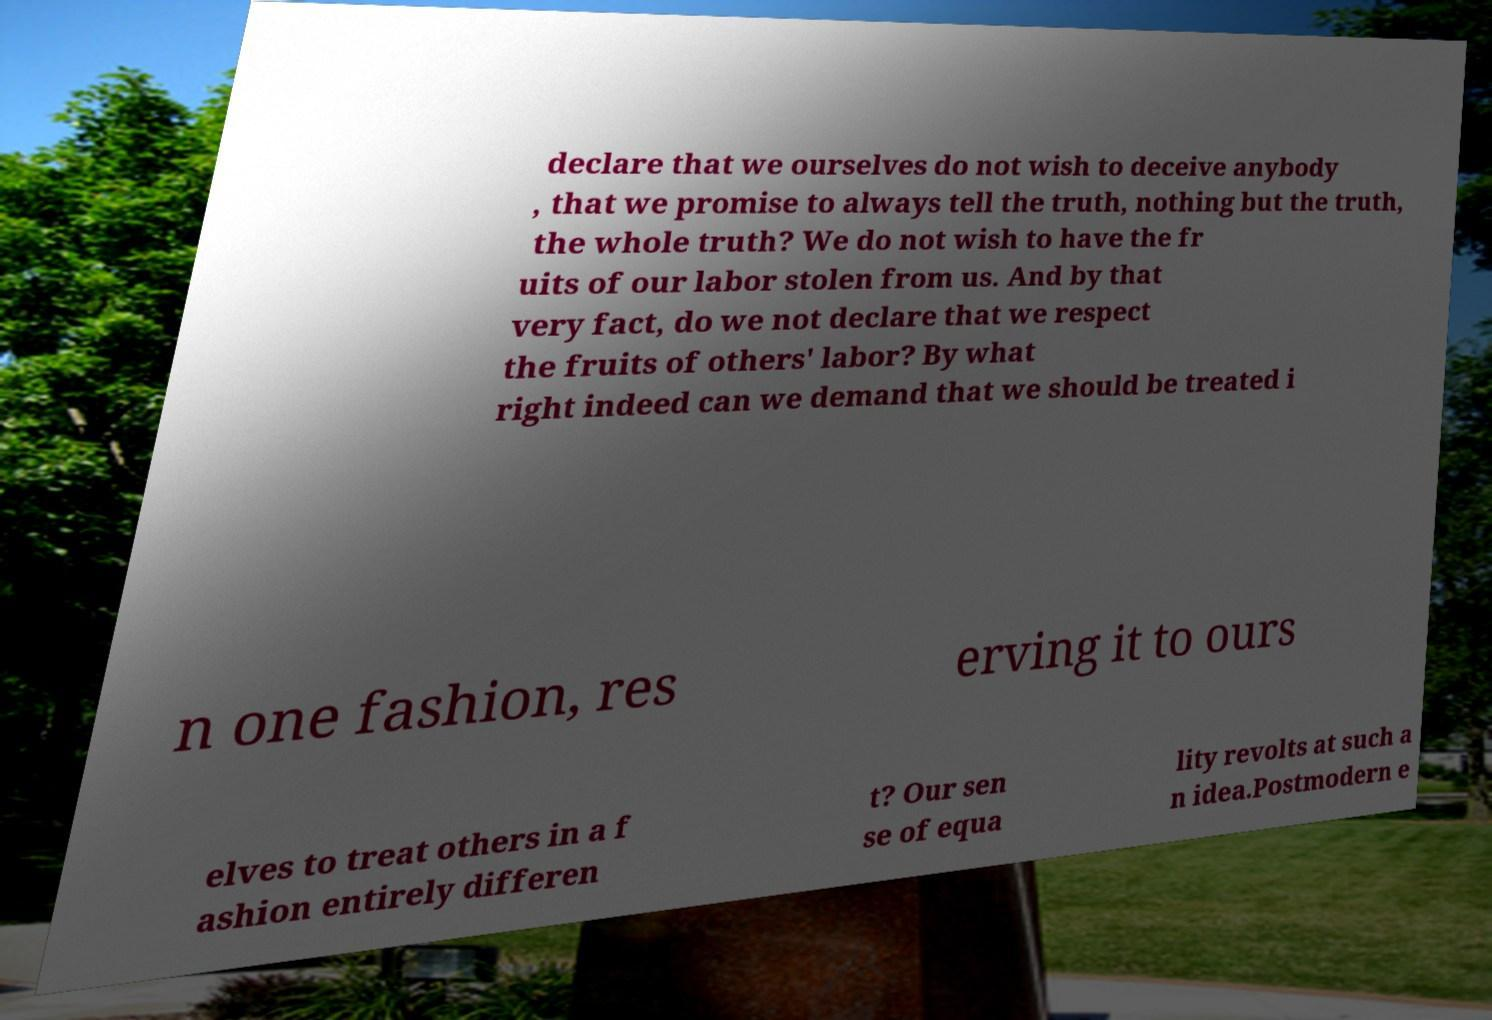Could you extract and type out the text from this image? declare that we ourselves do not wish to deceive anybody , that we promise to always tell the truth, nothing but the truth, the whole truth? We do not wish to have the fr uits of our labor stolen from us. And by that very fact, do we not declare that we respect the fruits of others' labor? By what right indeed can we demand that we should be treated i n one fashion, res erving it to ours elves to treat others in a f ashion entirely differen t? Our sen se of equa lity revolts at such a n idea.Postmodern e 